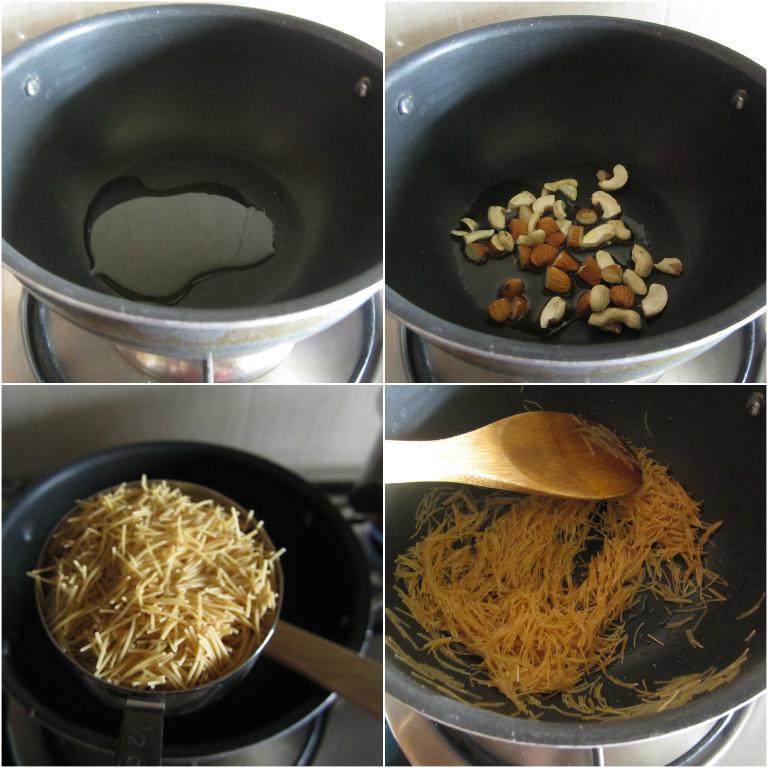Please provide a concise description of this image. In the image we can see collage photos. In the collage photos we can see the container and in the container we can see food item. Here we can see curry spoon and liquid in the container. 